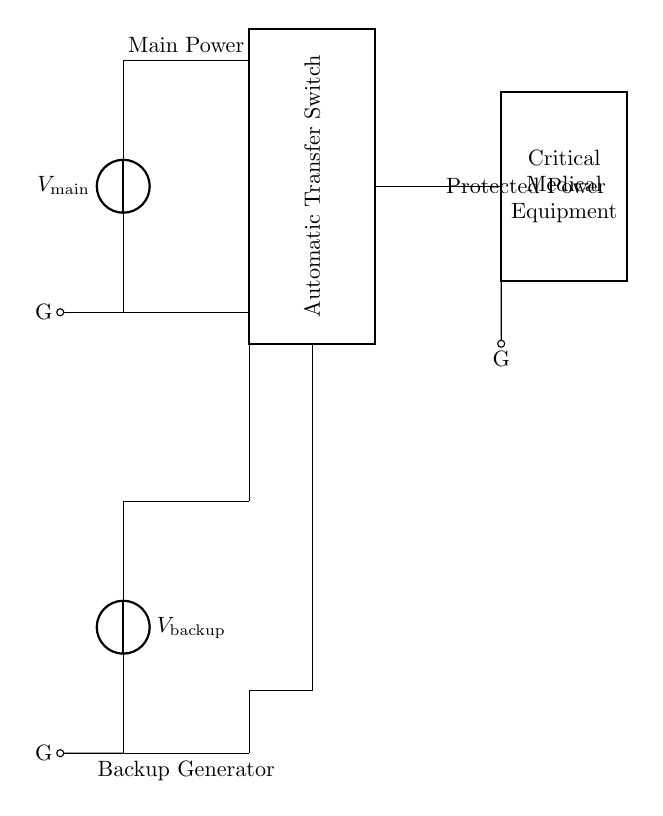What is the main power supply voltage? The circuit shows a voltage source labeled as V_main, indicating it is the main power supply. The exact voltage value is not specified in the diagram, but it is understood to be the primary source when available.
Answer: V_main What does the thick rectangle represent in this circuit? The thick rectangle labeled as "Automatic Transfer Switch" represents the component responsible for switching the load between the main power supply and the backup generator based on the availability of power.
Answer: Automatic Transfer Switch How many power sources are present in this circuit? The circuit features two power sources: the main power supply (V_main) and the backup generator (V_backup), providing redundancy in case one fails.
Answer: Two What is the role of the backup generator? The backup generator (labeled as V_backup) serves as an additional power source that activates when the main power supply is unavailable, ensuring continuous power to critical medical equipment.
Answer: Backup power source What is connected to the output of the Automatic Transfer Switch? The output line of the Automatic Transfer Switch leads to a block labeled "Critical Medical Equipment," which indicates that the switch connects and powers this equipment when needed.
Answer: Critical Medical Equipment What is indicated by the ground connections in the diagram? The ground connections anchor to the main power supply, backup generator, and critical medical equipment, ensuring safety by providing a common return path for electrical current, preventing dangerous voltage build-up.
Answer: Ground connections When does the Automatic Transfer Switch activate the backup generator? The Automatic Transfer Switch activates the backup generator when the main power supply (V_main) fails or sweeps below a predetermined threshold, automatically redirecting the load to maintain power.
Answer: During main power failure 